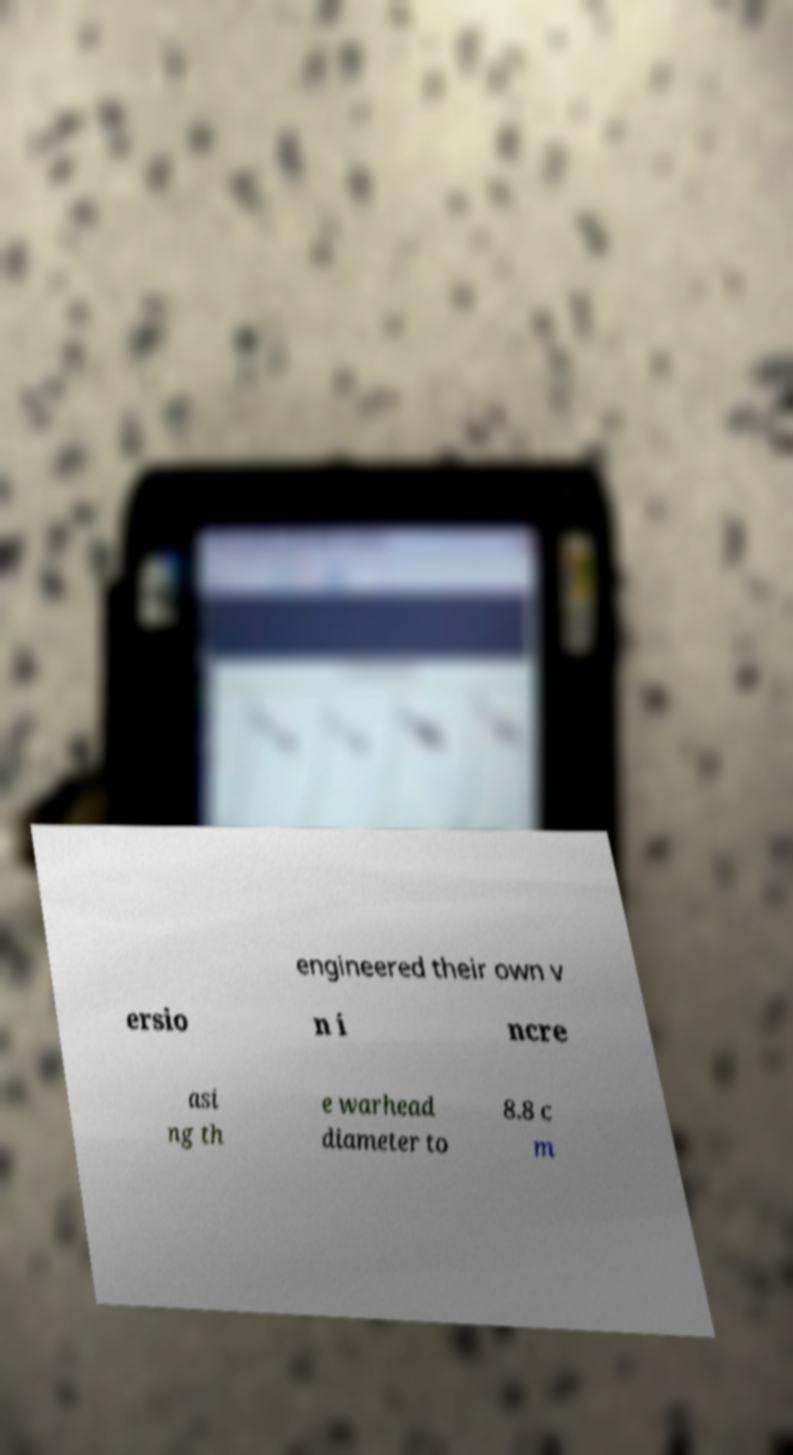Could you extract and type out the text from this image? engineered their own v ersio n i ncre asi ng th e warhead diameter to 8.8 c m 